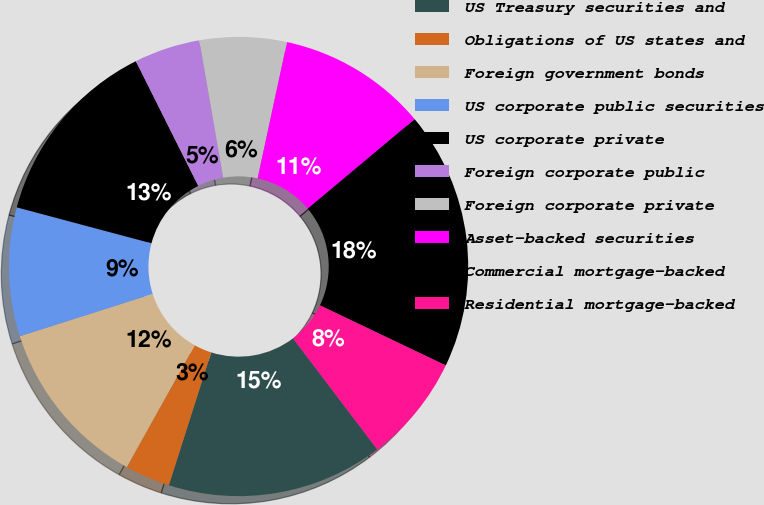<chart> <loc_0><loc_0><loc_500><loc_500><pie_chart><fcel>US Treasury securities and<fcel>Obligations of US states and<fcel>Foreign government bonds<fcel>US corporate public securities<fcel>US corporate private<fcel>Foreign corporate public<fcel>Foreign corporate private<fcel>Asset-backed securities<fcel>Commercial mortgage-backed<fcel>Residential mortgage-backed<nl><fcel>15.24%<fcel>3.18%<fcel>12.0%<fcel>9.06%<fcel>13.47%<fcel>4.65%<fcel>6.12%<fcel>10.53%<fcel>18.18%<fcel>7.59%<nl></chart> 